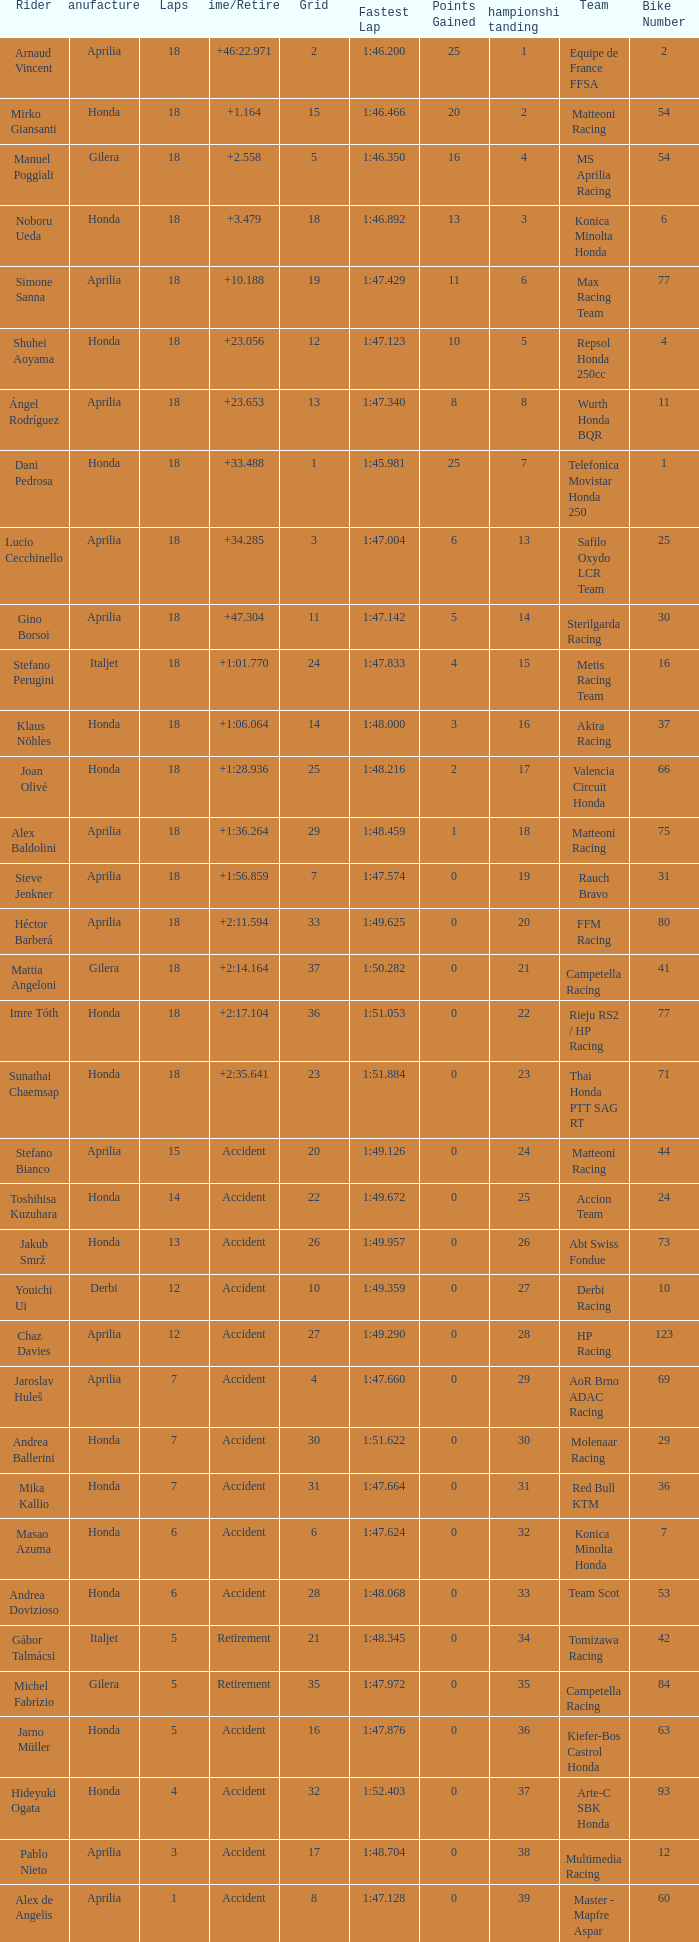What is the average number of laps with an accident time/retired, aprilia manufacturer and a grid of 27? 12.0. 